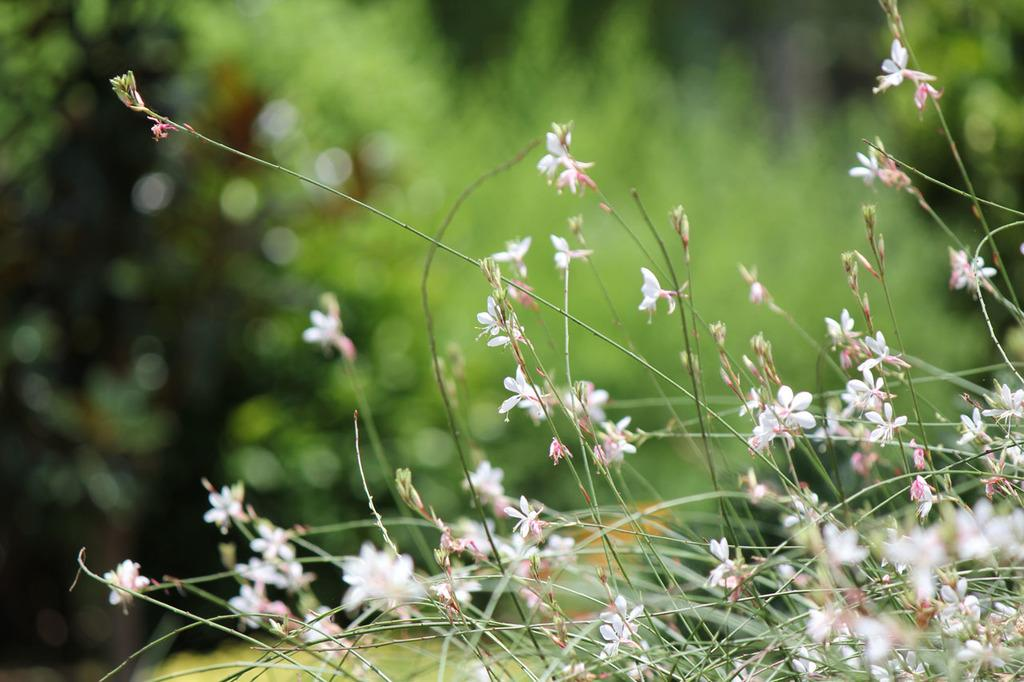What type of plants are in the front of the image? There are flowers in the front of the image. Can you describe the background of the image? The background of the image is blurry. What advice does the aunt give about the war in the image? There is no mention of an aunt or a war in the image; it only features flowers in the front and a blurry background. 